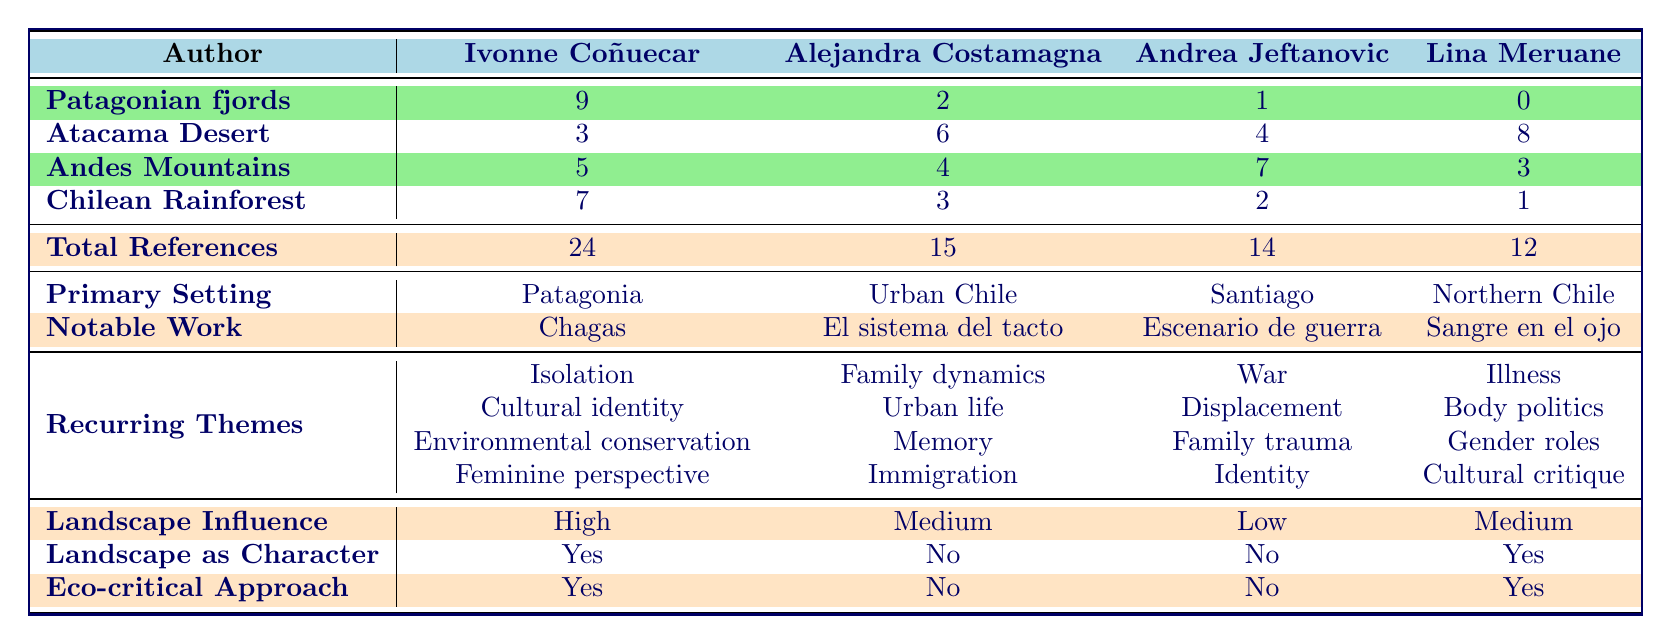What is the total number of landscape references in Ivonne Coñuecar's work? The table shows that Ivonne Coñuecar has a total of 24 landscape references listed under the "Total References" row.
Answer: 24 Which author has the highest references to the Patagonian fjords? According to the table, Ivonne Coñuecar has the highest references to the Patagonian fjords with a total of 9.
Answer: Ivonne Coñuecar How many more references to the Atacama Desert does Lina Meruane have compared to Andrea Jeftanovic? Lina Meruane has 8 references to the Atacama Desert while Andrea Jeftanovic has 4. The difference is 8 - 4 = 4.
Answer: 4 Is there a recurring theme of "Environmental conservation" found in Alejandra Costamagna's work? The table indicates that the recurring themes for Alejandra Costamagna do not include "Environmental conservation". Therefore, the answer is no.
Answer: No Which author has "Patagonia" as their primary setting? The table clearly states that Ivonne Coñuecar's primary setting is "Patagonia".
Answer: Ivonne Coñuecar How many total landscape references do the authors have when combined? Summing the total landscape references: 24 (Coñuecar) + 15 (Costamagna) + 14 (Jeftanovic) + 12 (Meruane) gives a total of 24 + 15 + 14 + 12 = 65.
Answer: 65 Do any of the authors employ an eco-critical approach in their work? The table shows that both Ivonne Coñuecar and Lina Meruane have an eco-critical approach, indicating that the answer is yes for these authors.
Answer: Yes What landscape feature is most emphasized by Andrea Jeftanovic in her work? According to the table, Andrea Jeftanovic has the most references to the Andes Mountains, totaling 7 references, which is her highest landscape feature.
Answer: Andes Mountains What is the landscape influence level of Alejandra Costamagna? The table indicates that Alejandra Costamagna has a "Medium" landscape influence level.
Answer: Medium 